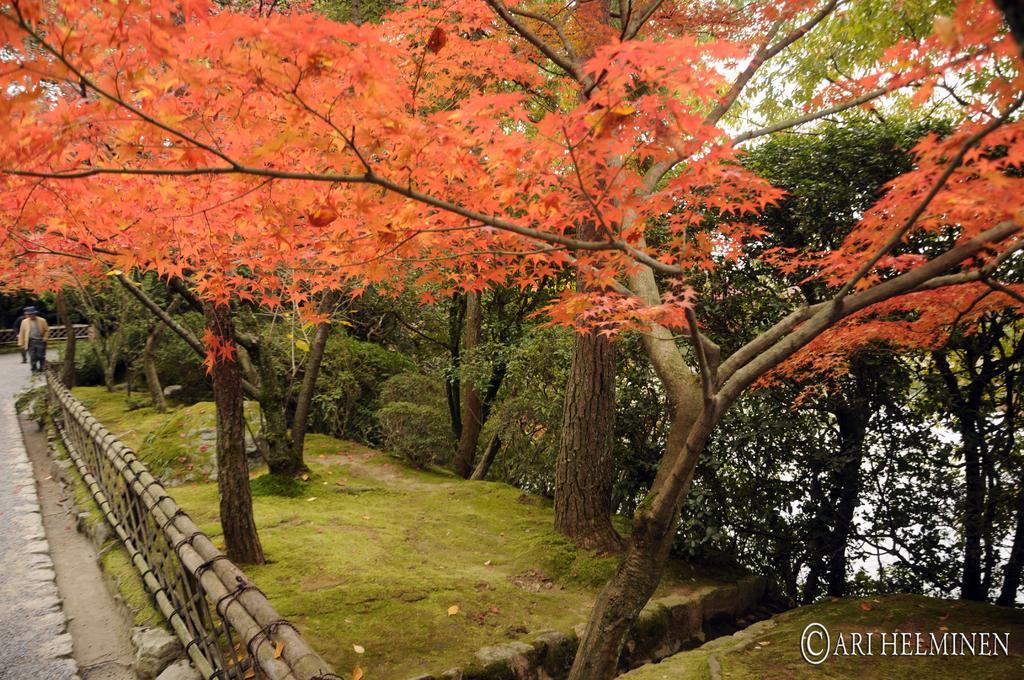Can you describe this image briefly? In this picture there are trees. At the back there is a person standing on the road and there is a wooden railing. At the top there is sky. At the bottom there is road and there is grass. At the bottom right there is text. In the foreground there are red color leaves on the trees. 